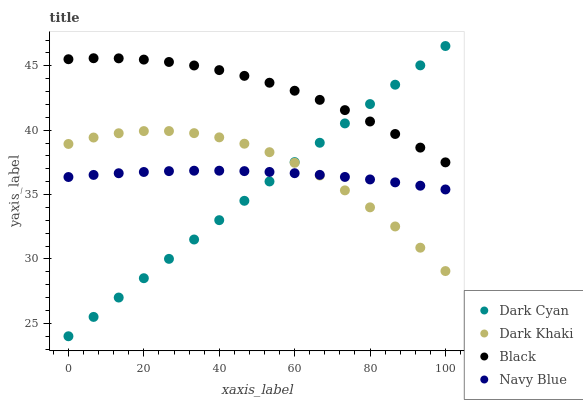Does Dark Cyan have the minimum area under the curve?
Answer yes or no. Yes. Does Black have the maximum area under the curve?
Answer yes or no. Yes. Does Dark Khaki have the minimum area under the curve?
Answer yes or no. No. Does Dark Khaki have the maximum area under the curve?
Answer yes or no. No. Is Dark Cyan the smoothest?
Answer yes or no. Yes. Is Dark Khaki the roughest?
Answer yes or no. Yes. Is Black the smoothest?
Answer yes or no. No. Is Black the roughest?
Answer yes or no. No. Does Dark Cyan have the lowest value?
Answer yes or no. Yes. Does Dark Khaki have the lowest value?
Answer yes or no. No. Does Dark Cyan have the highest value?
Answer yes or no. Yes. Does Dark Khaki have the highest value?
Answer yes or no. No. Is Dark Khaki less than Black?
Answer yes or no. Yes. Is Black greater than Navy Blue?
Answer yes or no. Yes. Does Dark Cyan intersect Dark Khaki?
Answer yes or no. Yes. Is Dark Cyan less than Dark Khaki?
Answer yes or no. No. Is Dark Cyan greater than Dark Khaki?
Answer yes or no. No. Does Dark Khaki intersect Black?
Answer yes or no. No. 